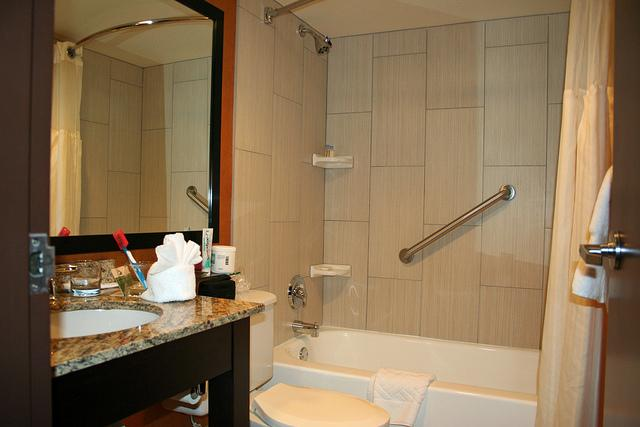What is the blue/white/red item by the sink?

Choices:
A) toothbrush
B) bikini trimmer
C) toilet brush
D) nail clippers toothbrush 